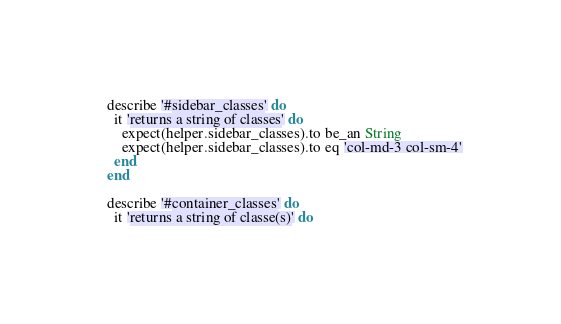Convert code to text. <code><loc_0><loc_0><loc_500><loc_500><_Ruby_>
  describe '#sidebar_classes' do
    it 'returns a string of classes' do
      expect(helper.sidebar_classes).to be_an String
      expect(helper.sidebar_classes).to eq 'col-md-3 col-sm-4'
    end
  end

  describe '#container_classes' do
    it 'returns a string of classe(s)' do</code> 